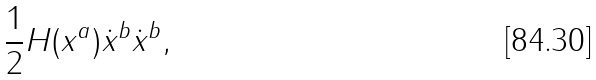<formula> <loc_0><loc_0><loc_500><loc_500>\frac { 1 } { 2 } H ( x ^ { a } ) \dot { x } ^ { b } \dot { x } ^ { b } ,</formula> 